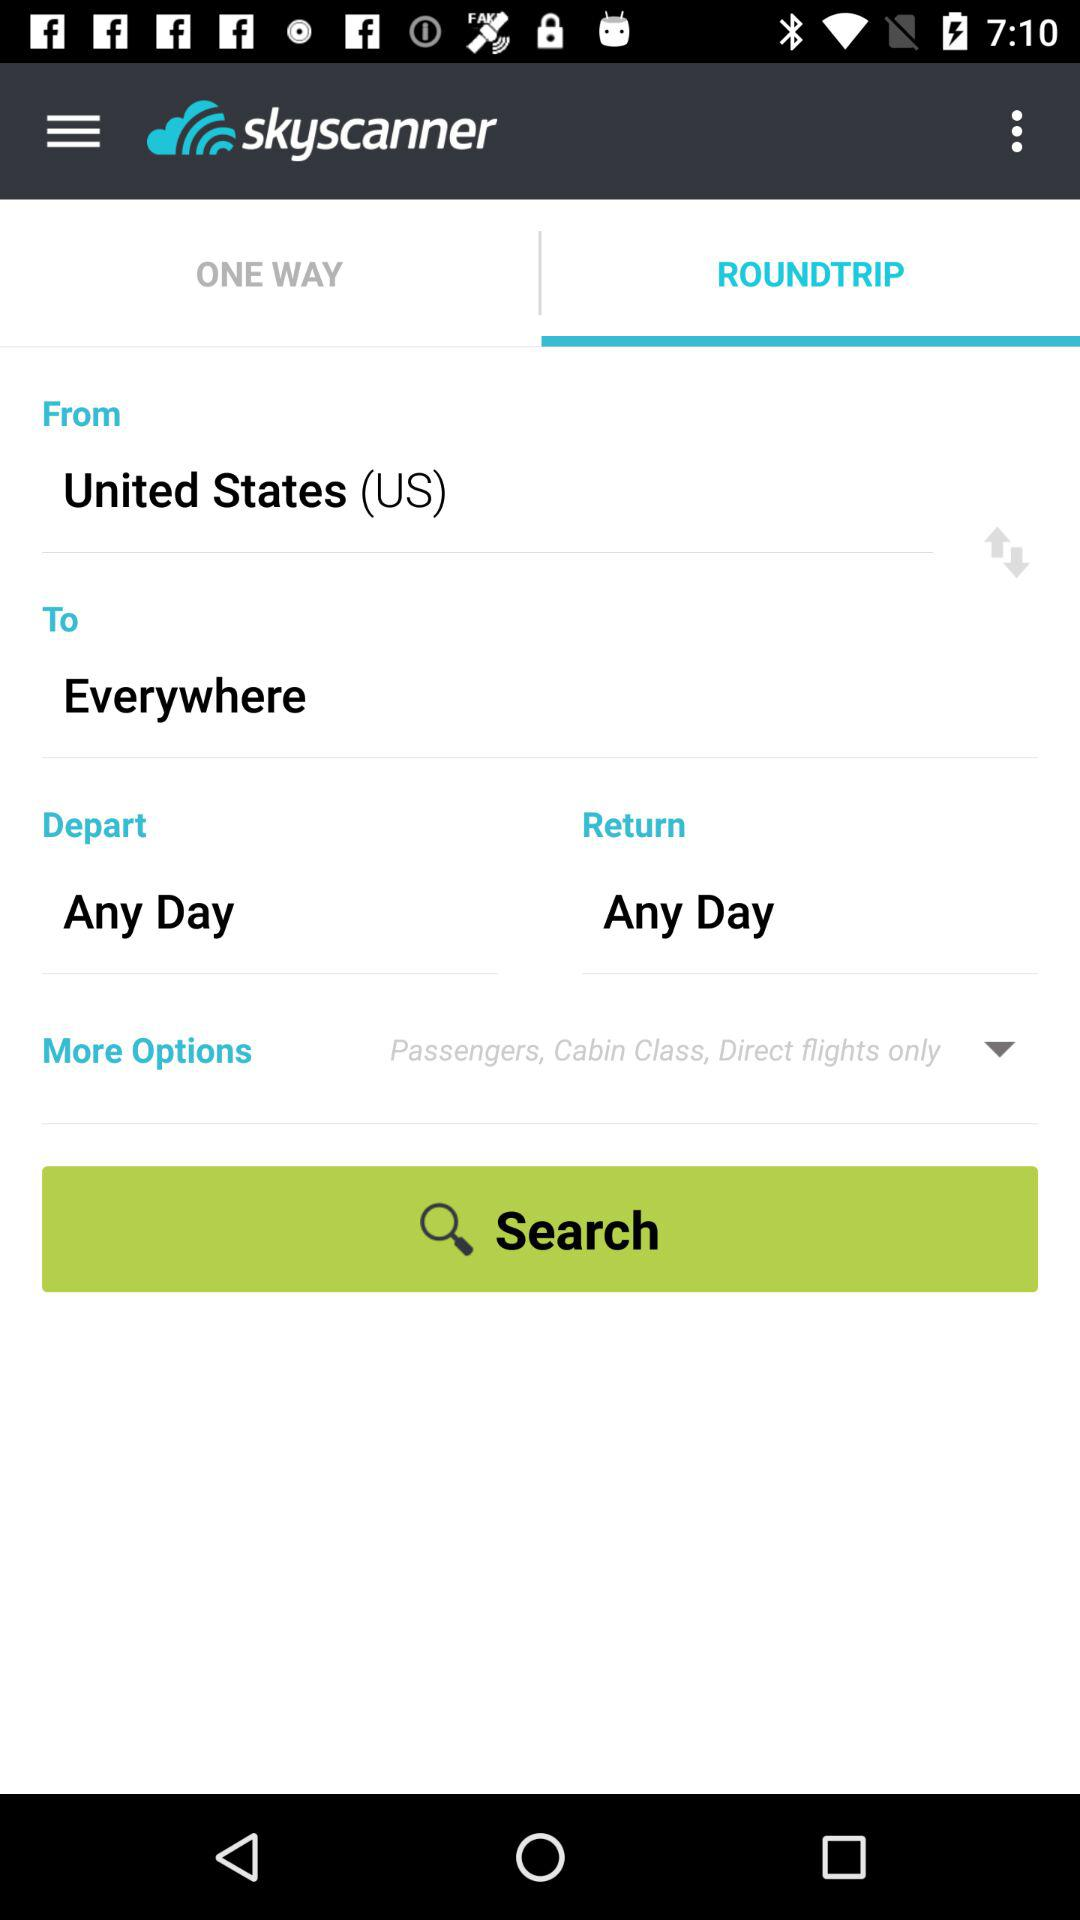Which is the departure location? The departure location is the United States (US). 